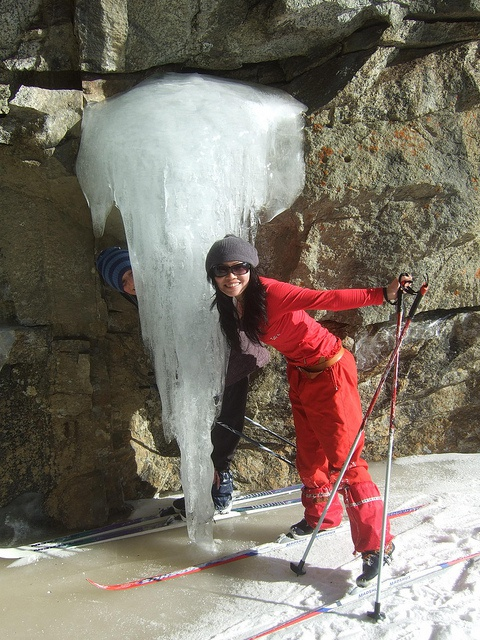Describe the objects in this image and their specific colors. I can see people in black, maroon, brown, and salmon tones, skis in black, lightgray, darkgray, gray, and lightpink tones, skis in black, gray, white, and darkgray tones, and people in black, brown, and maroon tones in this image. 